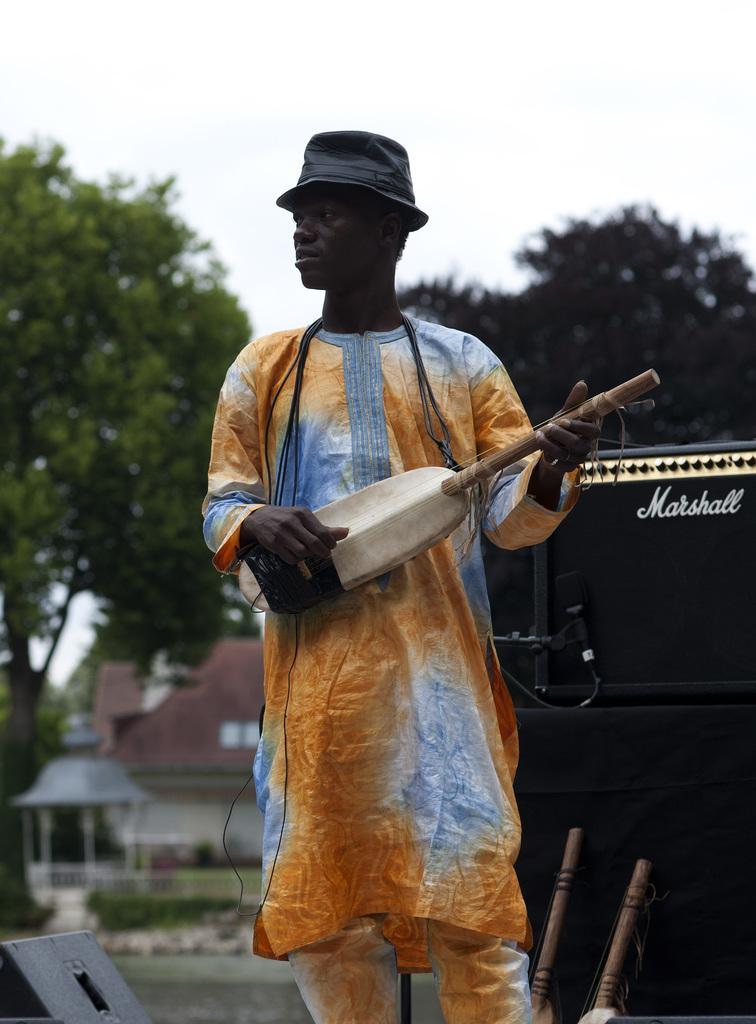In one or two sentences, can you explain what this image depicts? In the center of the picture there is a person standing wearing a hat and playing a musical instrument. On the right there are speakers and other musical instruments. The background is blurred. In the background there are trees and buildings. 